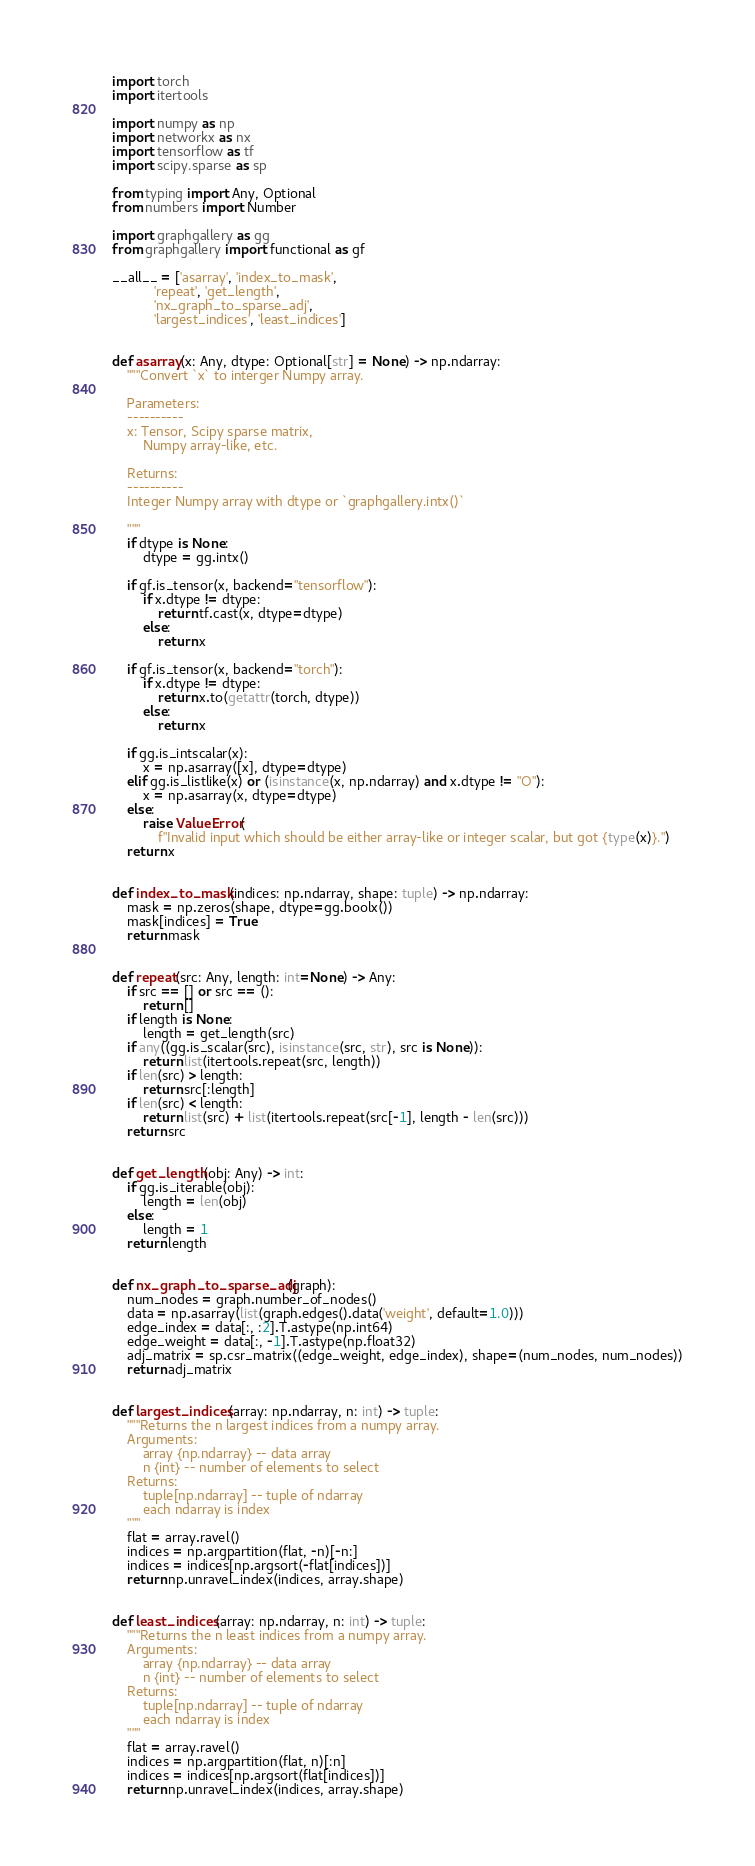Convert code to text. <code><loc_0><loc_0><loc_500><loc_500><_Python_>import torch
import itertools

import numpy as np
import networkx as nx
import tensorflow as tf
import scipy.sparse as sp

from typing import Any, Optional
from numbers import Number

import graphgallery as gg
from graphgallery import functional as gf

__all__ = ['asarray', 'index_to_mask',
           'repeat', 'get_length',
           'nx_graph_to_sparse_adj', 
           'largest_indices', 'least_indices']


def asarray(x: Any, dtype: Optional[str] = None) -> np.ndarray:
    """Convert `x` to interger Numpy array.

    Parameters:
    ----------
    x: Tensor, Scipy sparse matrix,
        Numpy array-like, etc.

    Returns:
    ----------
    Integer Numpy array with dtype or `graphgallery.intx()`

    """
    if dtype is None:
        dtype = gg.intx()

    if gf.is_tensor(x, backend="tensorflow"):
        if x.dtype != dtype:
            return tf.cast(x, dtype=dtype)
        else:
            return x

    if gf.is_tensor(x, backend="torch"):
        if x.dtype != dtype:
            return x.to(getattr(torch, dtype))
        else:
            return x

    if gg.is_intscalar(x):
        x = np.asarray([x], dtype=dtype)
    elif gg.is_listlike(x) or (isinstance(x, np.ndarray) and x.dtype != "O"):
        x = np.asarray(x, dtype=dtype)
    else:
        raise ValueError(
            f"Invalid input which should be either array-like or integer scalar, but got {type(x)}.")
    return x


def index_to_mask(indices: np.ndarray, shape: tuple) -> np.ndarray:
    mask = np.zeros(shape, dtype=gg.boolx())
    mask[indices] = True
    return mask


def repeat(src: Any, length: int=None) -> Any:
    if src == [] or src == ():
        return []
    if length is None:
        length = get_length(src)
    if any((gg.is_scalar(src), isinstance(src, str), src is None)):
        return list(itertools.repeat(src, length))
    if len(src) > length:
        return src[:length]
    if len(src) < length:
        return list(src) + list(itertools.repeat(src[-1], length - len(src)))
    return src


def get_length(obj: Any) -> int:
    if gg.is_iterable(obj):
        length = len(obj)
    else:
        length = 1
    return length


def nx_graph_to_sparse_adj(graph):
    num_nodes = graph.number_of_nodes()
    data = np.asarray(list(graph.edges().data('weight', default=1.0)))
    edge_index = data[:, :2].T.astype(np.int64)
    edge_weight = data[:, -1].T.astype(np.float32)
    adj_matrix = sp.csr_matrix((edge_weight, edge_index), shape=(num_nodes, num_nodes))
    return adj_matrix


def largest_indices(array: np.ndarray, n: int) -> tuple:
    """Returns the n largest indices from a numpy array.
    Arguments:
        array {np.ndarray} -- data array
        n {int} -- number of elements to select
    Returns:
        tuple[np.ndarray] -- tuple of ndarray
        each ndarray is index
    """
    flat = array.ravel()
    indices = np.argpartition(flat, -n)[-n:]
    indices = indices[np.argsort(-flat[indices])]
    return np.unravel_index(indices, array.shape)


def least_indices(array: np.ndarray, n: int) -> tuple:
    """Returns the n least indices from a numpy array.
    Arguments:
        array {np.ndarray} -- data array
        n {int} -- number of elements to select
    Returns:
        tuple[np.ndarray] -- tuple of ndarray
        each ndarray is index
    """
    flat = array.ravel()
    indices = np.argpartition(flat, n)[:n]
    indices = indices[np.argsort(flat[indices])]
    return np.unravel_index(indices, array.shape)

</code> 